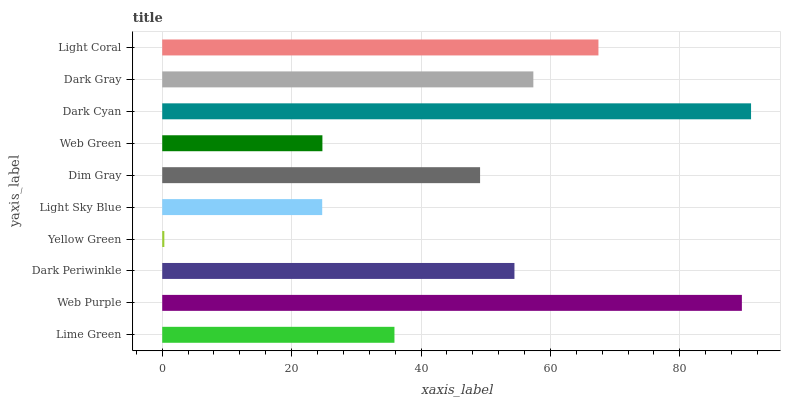Is Yellow Green the minimum?
Answer yes or no. Yes. Is Dark Cyan the maximum?
Answer yes or no. Yes. Is Web Purple the minimum?
Answer yes or no. No. Is Web Purple the maximum?
Answer yes or no. No. Is Web Purple greater than Lime Green?
Answer yes or no. Yes. Is Lime Green less than Web Purple?
Answer yes or no. Yes. Is Lime Green greater than Web Purple?
Answer yes or no. No. Is Web Purple less than Lime Green?
Answer yes or no. No. Is Dark Periwinkle the high median?
Answer yes or no. Yes. Is Dim Gray the low median?
Answer yes or no. Yes. Is Light Sky Blue the high median?
Answer yes or no. No. Is Web Purple the low median?
Answer yes or no. No. 